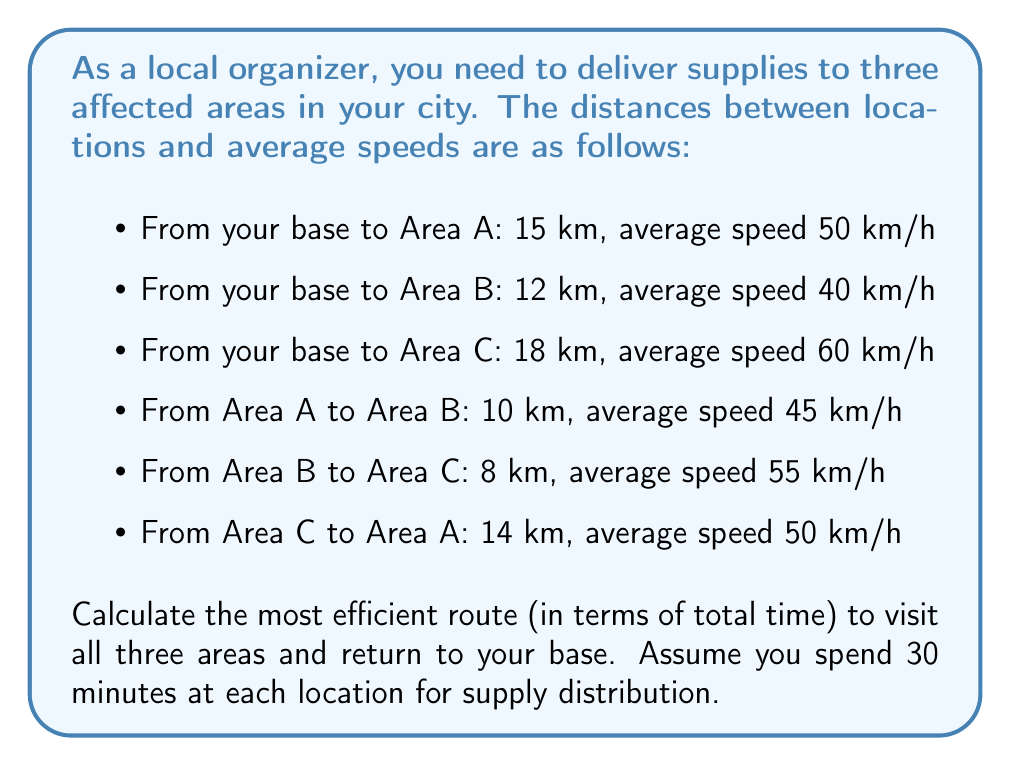Solve this math problem. To solve this problem, we need to calculate the time for each possible route and compare them. Let's use the formula:

$$ \text{Time} = \frac{\text{Distance}}{\text{Speed}} + \text{Distribution Time} $$

There are six possible routes to visit all three areas:

1. Base → A → B → C → Base
2. Base → A → C → B → Base
3. Base → B → A → C → Base
4. Base → B → C → A → Base
5. Base → C → A → B → Base
6. Base → C → B → A → Base

Let's calculate the time for each route:

Route 1: Base → A → B → C → Base
$$ T_1 = \frac{15}{50} + \frac{10}{45} + \frac{8}{55} + \frac{18}{60} + 1.5 = 3.97 \text{ hours} $$

Route 2: Base → A → C → B → Base
$$ T_2 = \frac{15}{50} + \frac{14}{50} + \frac{8}{55} + \frac{12}{40} + 1.5 = 4.12 \text{ hours} $$

Route 3: Base → B → A → C → Base
$$ T_3 = \frac{12}{40} + \frac{10}{45} + \frac{14}{50} + \frac{18}{60} + 1.5 = 4.17 \text{ hours} $$

Route 4: Base → B → C → A → Base
$$ T_4 = \frac{12}{40} + \frac{8}{55} + \frac{14}{50} + \frac{15}{50} + 1.5 = 3.91 \text{ hours} $$

Route 5: Base → C → A → B → Base
$$ T_5 = \frac{18}{60} + \frac{14}{50} + \frac{10}{45} + \frac{12}{40} + 1.5 = 4.07 \text{ hours} $$

Route 6: Base → C → B → A → Base
$$ T_6 = \frac{18}{60} + \frac{8}{55} + \frac{10}{45} + \frac{15}{50} + 1.5 = 3.86 \text{ hours} $$

Comparing all the routes, we can see that Route 6 (Base → C → B → A → Base) has the shortest total time.
Answer: The most efficient route is Base → C → B → A → Base, with a total time of 3.86 hours. 